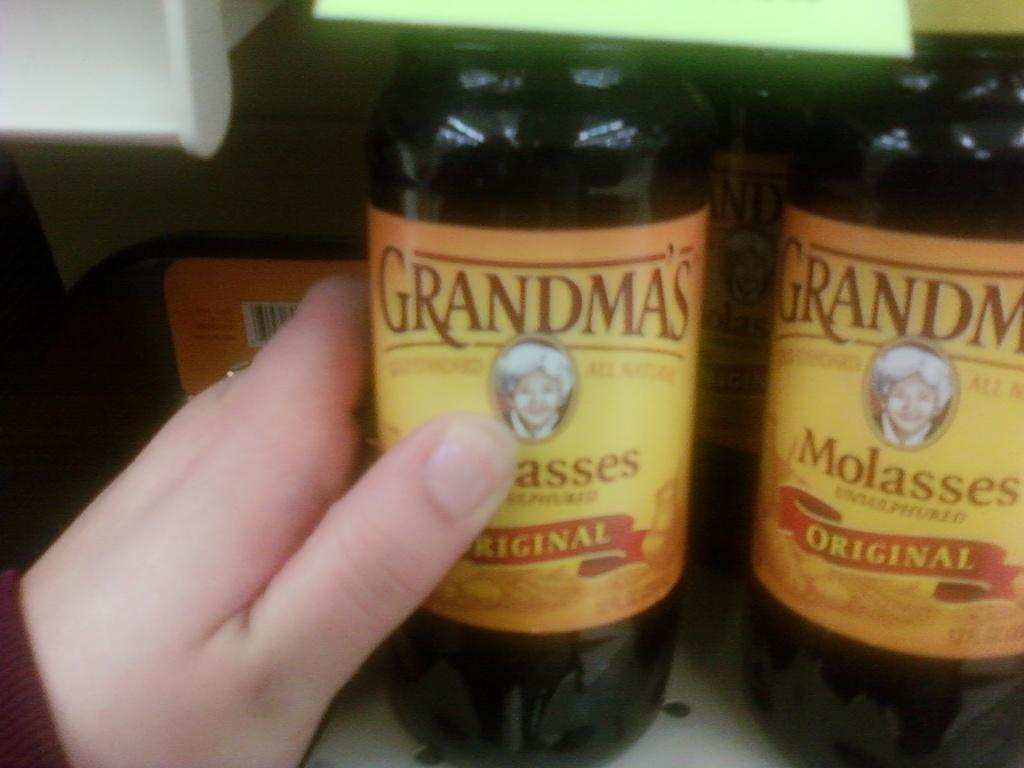<image>
Offer a succinct explanation of the picture presented. A person holding a bottle of Grandma's Molasses in the original. 